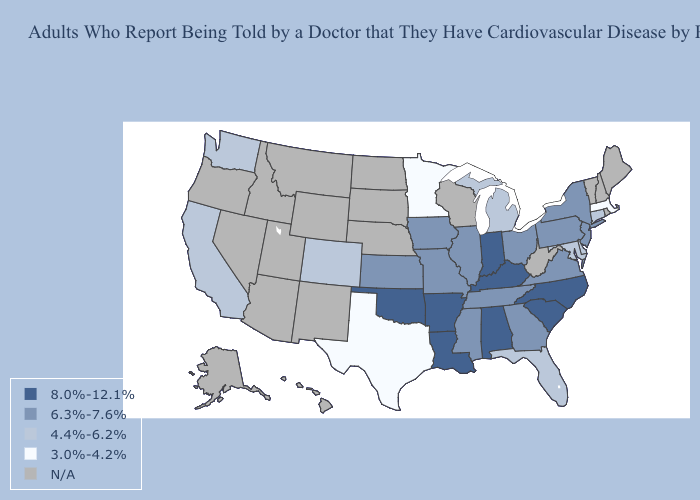What is the value of Arizona?
Write a very short answer. N/A. Among the states that border Wisconsin , does Michigan have the highest value?
Short answer required. No. What is the highest value in the South ?
Answer briefly. 8.0%-12.1%. What is the value of Georgia?
Answer briefly. 6.3%-7.6%. Which states have the highest value in the USA?
Give a very brief answer. Alabama, Arkansas, Indiana, Kentucky, Louisiana, North Carolina, Oklahoma, South Carolina. What is the value of Kentucky?
Write a very short answer. 8.0%-12.1%. What is the value of Florida?
Quick response, please. 4.4%-6.2%. Is the legend a continuous bar?
Quick response, please. No. Does the first symbol in the legend represent the smallest category?
Be succinct. No. Does Florida have the lowest value in the USA?
Give a very brief answer. No. What is the highest value in the Northeast ?
Write a very short answer. 6.3%-7.6%. What is the value of Hawaii?
Short answer required. N/A. Does the first symbol in the legend represent the smallest category?
Short answer required. No. Name the states that have a value in the range 6.3%-7.6%?
Keep it brief. Georgia, Illinois, Iowa, Kansas, Mississippi, Missouri, New Jersey, New York, Ohio, Pennsylvania, Tennessee, Virginia. Does the map have missing data?
Concise answer only. Yes. 